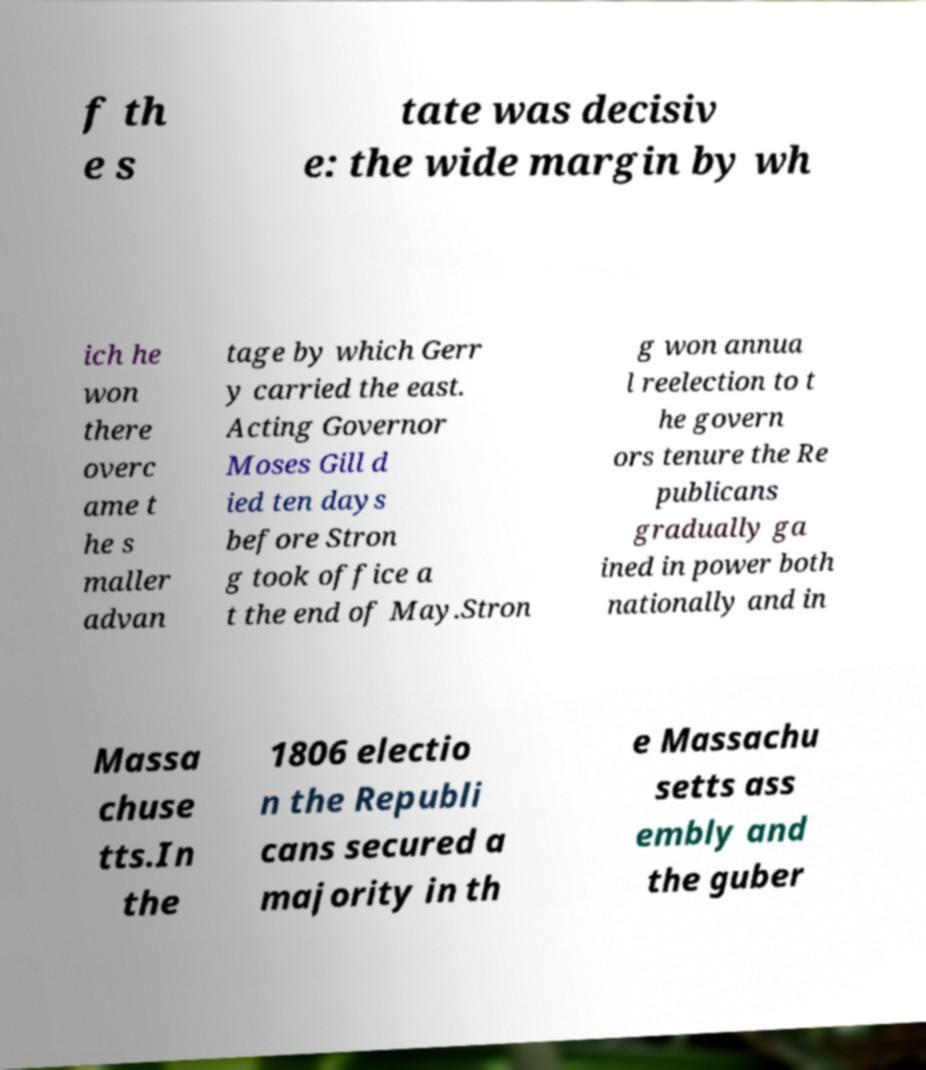Please identify and transcribe the text found in this image. f th e s tate was decisiv e: the wide margin by wh ich he won there overc ame t he s maller advan tage by which Gerr y carried the east. Acting Governor Moses Gill d ied ten days before Stron g took office a t the end of May.Stron g won annua l reelection to t he govern ors tenure the Re publicans gradually ga ined in power both nationally and in Massa chuse tts.In the 1806 electio n the Republi cans secured a majority in th e Massachu setts ass embly and the guber 